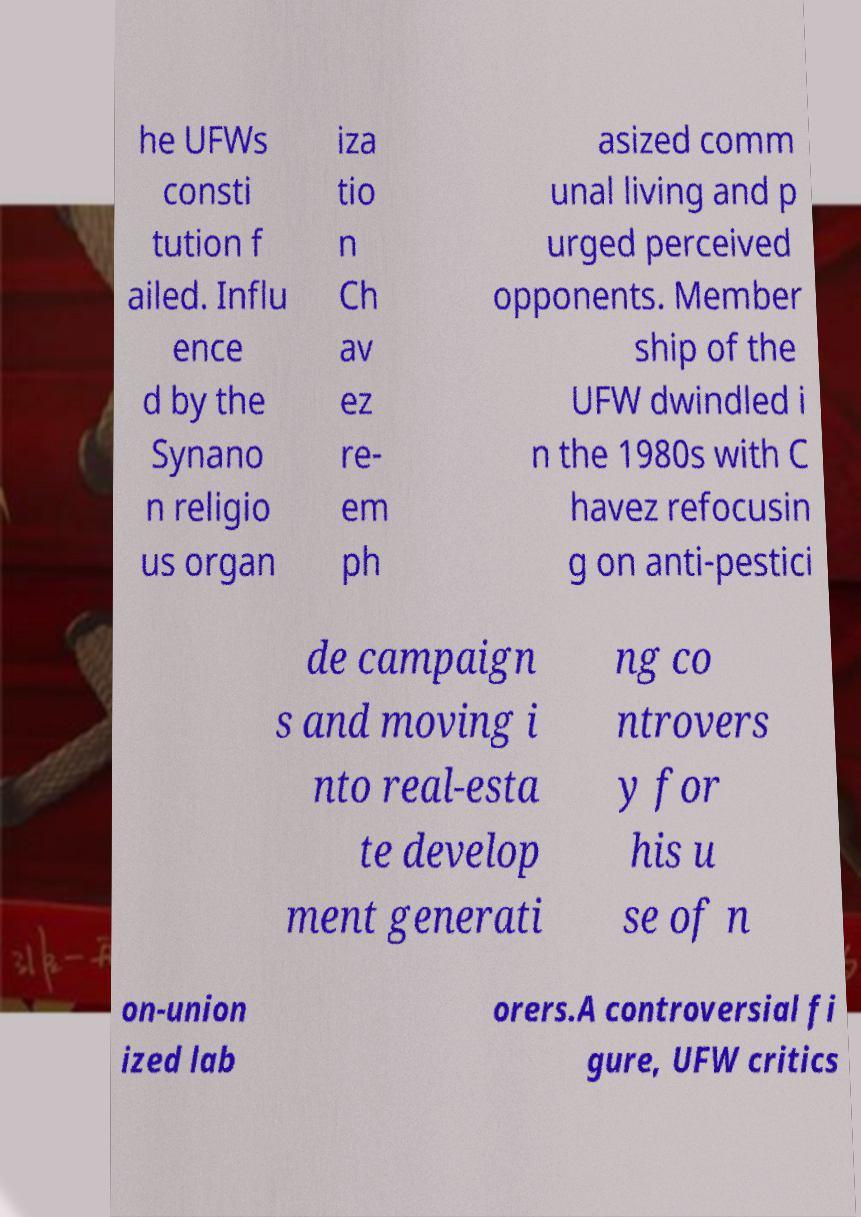What messages or text are displayed in this image? I need them in a readable, typed format. he UFWs consti tution f ailed. Influ ence d by the Synano n religio us organ iza tio n Ch av ez re- em ph asized comm unal living and p urged perceived opponents. Member ship of the UFW dwindled i n the 1980s with C havez refocusin g on anti-pestici de campaign s and moving i nto real-esta te develop ment generati ng co ntrovers y for his u se of n on-union ized lab orers.A controversial fi gure, UFW critics 